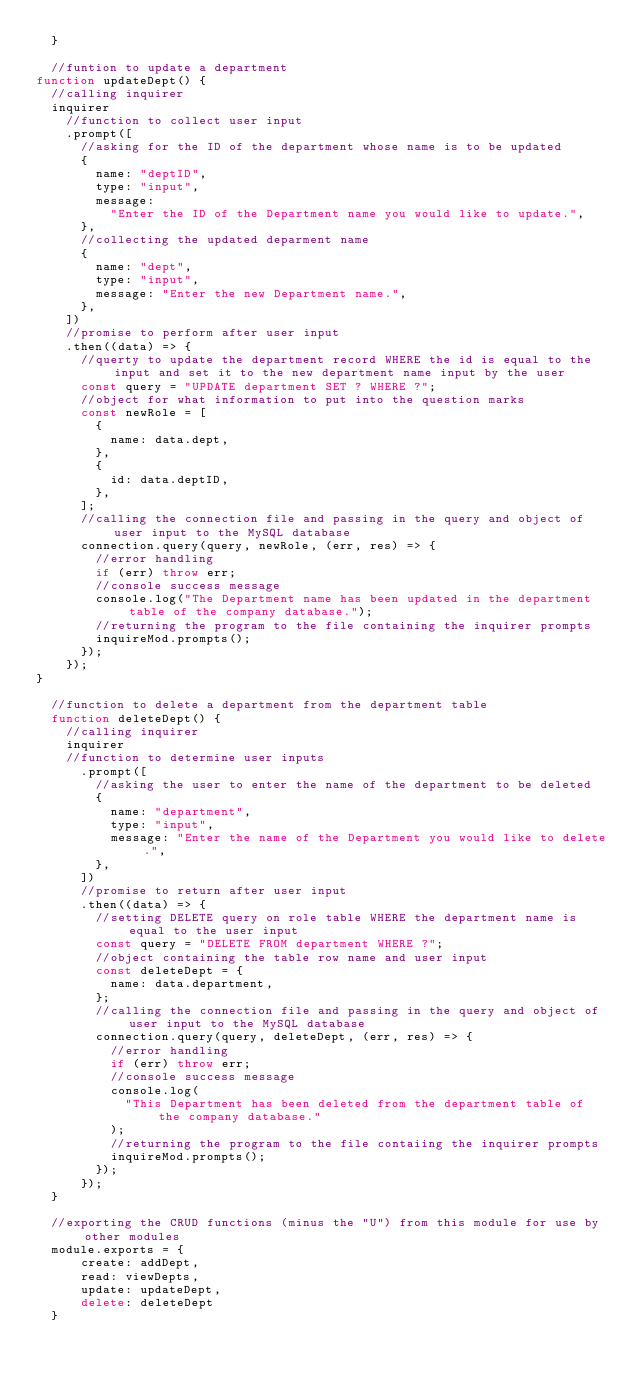Convert code to text. <code><loc_0><loc_0><loc_500><loc_500><_JavaScript_>  }

  //funtion to update a department
function updateDept() {
  //calling inquirer
  inquirer
    //function to collect user input
    .prompt([
      //asking for the ID of the department whose name is to be updated
      {
        name: "deptID",
        type: "input",
        message:
          "Enter the ID of the Department name you would like to update.",
      },
      //collecting the updated deparment name
      {
        name: "dept",
        type: "input",
        message: "Enter the new Department name.",
      },
    ])
    //promise to perform after user input
    .then((data) => {
      //querty to update the department record WHERE the id is equal to the input and set it to the new department name input by the user
      const query = "UPDATE department SET ? WHERE ?";
      //object for what information to put into the question marks
      const newRole = [
        {
          name: data.dept,
        },
        {
          id: data.deptID,
        },
      ];
      //calling the connection file and passing in the query and object of user input to the MySQL database
      connection.query(query, newRole, (err, res) => {
        //error handling
        if (err) throw err;
        //console success message
        console.log("The Department name has been updated in the department table of the company database.");
        //returning the program to the file containing the inquirer prompts
        inquireMod.prompts();
      });
    });
}

  //function to delete a department from the department table
  function deleteDept() {
    //calling inquirer
    inquirer
    //function to determine user inputs
      .prompt([
        //asking the user to enter the name of the department to be deleted
        {
          name: "department",
          type: "input",
          message: "Enter the name of the Department you would like to delete.",
        },
      ])
      //promise to return after user input
      .then((data) => {
        //setting DELETE query on role table WHERE the department name is equal to the user input
        const query = "DELETE FROM department WHERE ?";
        //object containing the table row name and user input
        const deleteDept = {
          name: data.department,
        };
        //calling the connection file and passing in the query and object of user input to the MySQL database
        connection.query(query, deleteDept, (err, res) => {
          //error handling
          if (err) throw err;
          //console success message
          console.log(
            "This Department has been deleted from the department table of the company database."
          );
          //returning the program to the file contaiing the inquirer prompts
          inquireMod.prompts();
        });
      });
  }

  //exporting the CRUD functions (minus the "U") from this module for use by other modules
  module.exports = {
      create: addDept,
      read: viewDepts,
      update: updateDept,
      delete: deleteDept
  }</code> 